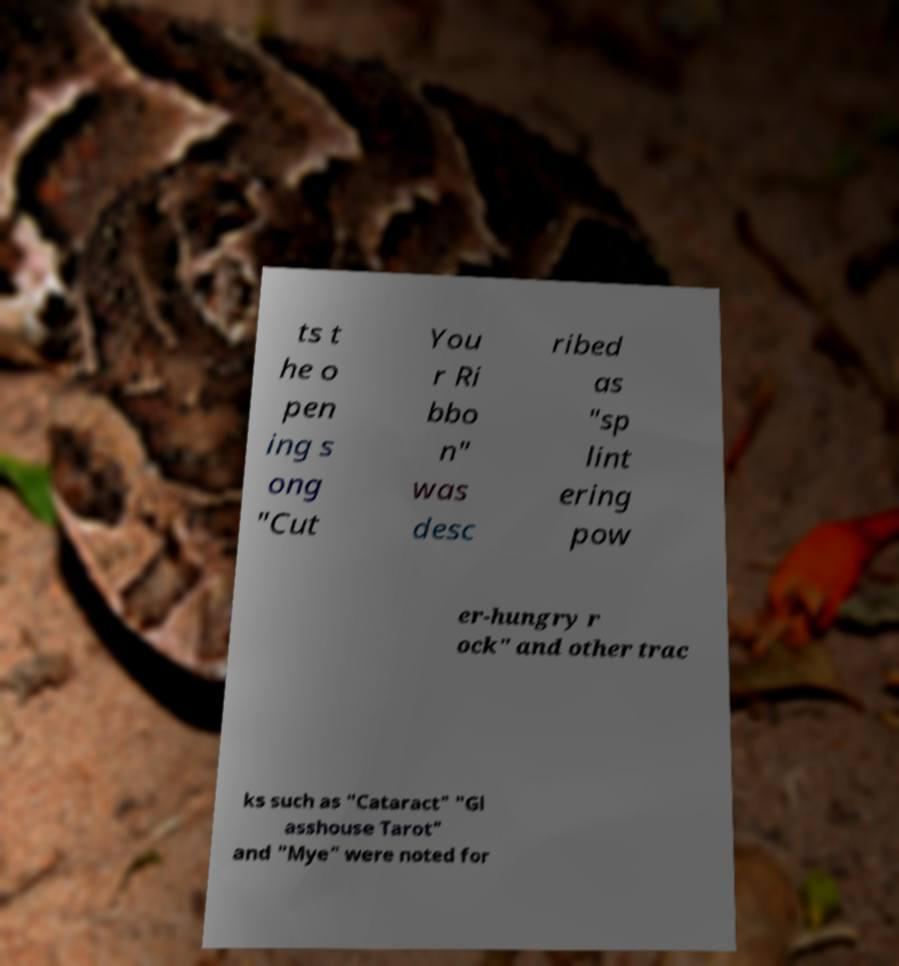Could you assist in decoding the text presented in this image and type it out clearly? ts t he o pen ing s ong "Cut You r Ri bbo n" was desc ribed as "sp lint ering pow er-hungry r ock" and other trac ks such as "Cataract" "Gl asshouse Tarot" and "Mye" were noted for 